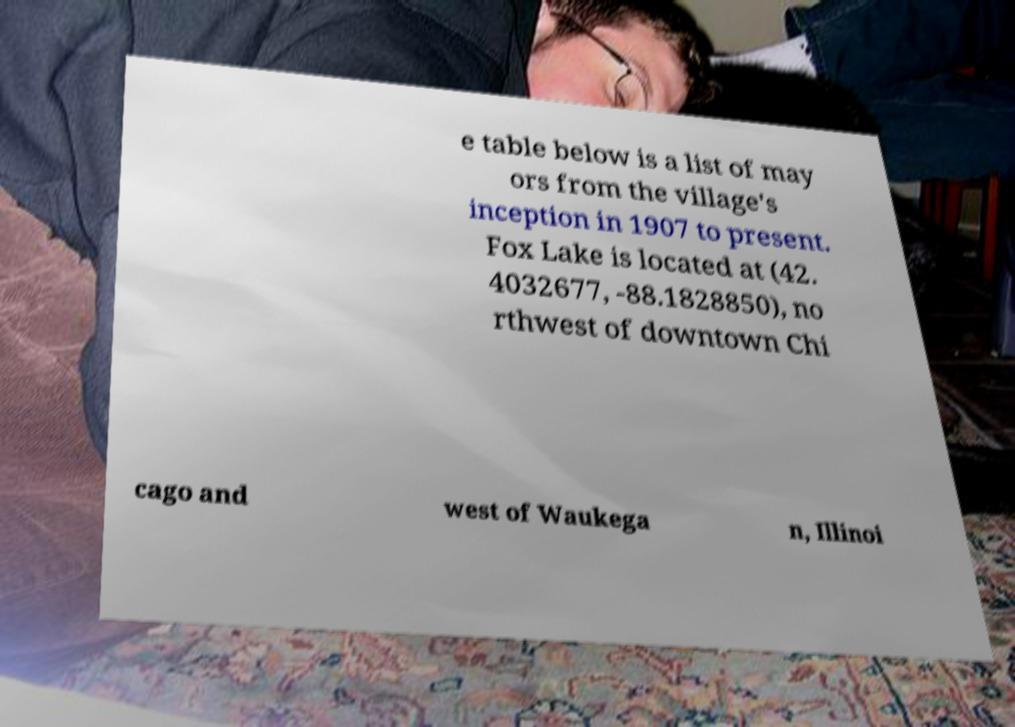Can you accurately transcribe the text from the provided image for me? e table below is a list of may ors from the village's inception in 1907 to present. Fox Lake is located at (42. 4032677, -88.1828850), no rthwest of downtown Chi cago and west of Waukega n, Illinoi 